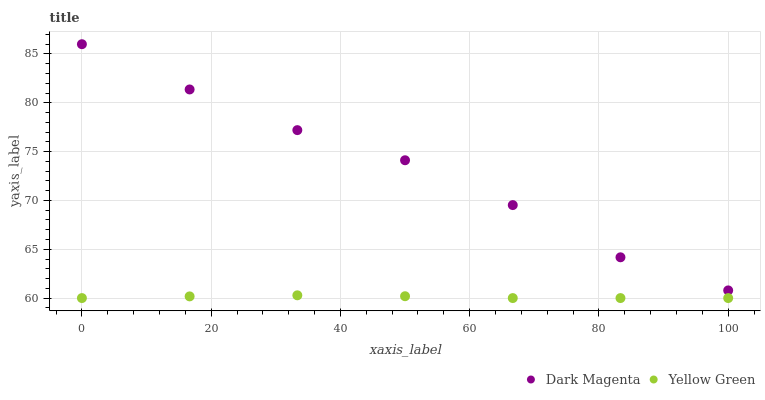Does Yellow Green have the minimum area under the curve?
Answer yes or no. Yes. Does Dark Magenta have the maximum area under the curve?
Answer yes or no. Yes. Does Yellow Green have the maximum area under the curve?
Answer yes or no. No. Is Yellow Green the smoothest?
Answer yes or no. Yes. Is Dark Magenta the roughest?
Answer yes or no. Yes. Is Yellow Green the roughest?
Answer yes or no. No. Does Yellow Green have the lowest value?
Answer yes or no. Yes. Does Dark Magenta have the highest value?
Answer yes or no. Yes. Does Yellow Green have the highest value?
Answer yes or no. No. Is Yellow Green less than Dark Magenta?
Answer yes or no. Yes. Is Dark Magenta greater than Yellow Green?
Answer yes or no. Yes. Does Yellow Green intersect Dark Magenta?
Answer yes or no. No. 